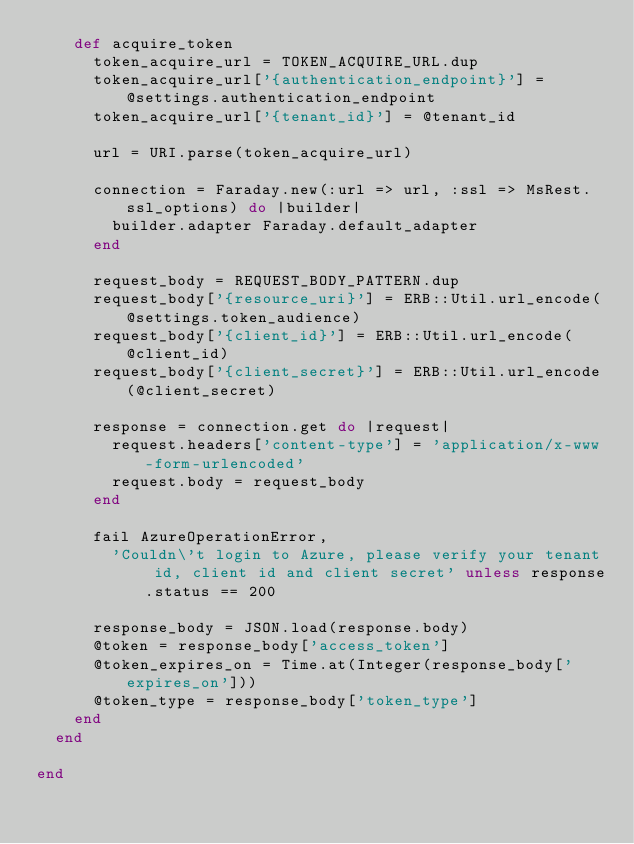Convert code to text. <code><loc_0><loc_0><loc_500><loc_500><_Ruby_>    def acquire_token
      token_acquire_url = TOKEN_ACQUIRE_URL.dup
      token_acquire_url['{authentication_endpoint}'] = @settings.authentication_endpoint
      token_acquire_url['{tenant_id}'] = @tenant_id

      url = URI.parse(token_acquire_url)

      connection = Faraday.new(:url => url, :ssl => MsRest.ssl_options) do |builder|
        builder.adapter Faraday.default_adapter
      end

      request_body = REQUEST_BODY_PATTERN.dup
      request_body['{resource_uri}'] = ERB::Util.url_encode(@settings.token_audience)
      request_body['{client_id}'] = ERB::Util.url_encode(@client_id)
      request_body['{client_secret}'] = ERB::Util.url_encode(@client_secret)

      response = connection.get do |request|
        request.headers['content-type'] = 'application/x-www-form-urlencoded'
        request.body = request_body
      end

      fail AzureOperationError,
        'Couldn\'t login to Azure, please verify your tenant id, client id and client secret' unless response.status == 200

      response_body = JSON.load(response.body)
      @token = response_body['access_token']
      @token_expires_on = Time.at(Integer(response_body['expires_on']))
      @token_type = response_body['token_type']
    end
  end

end
</code> 